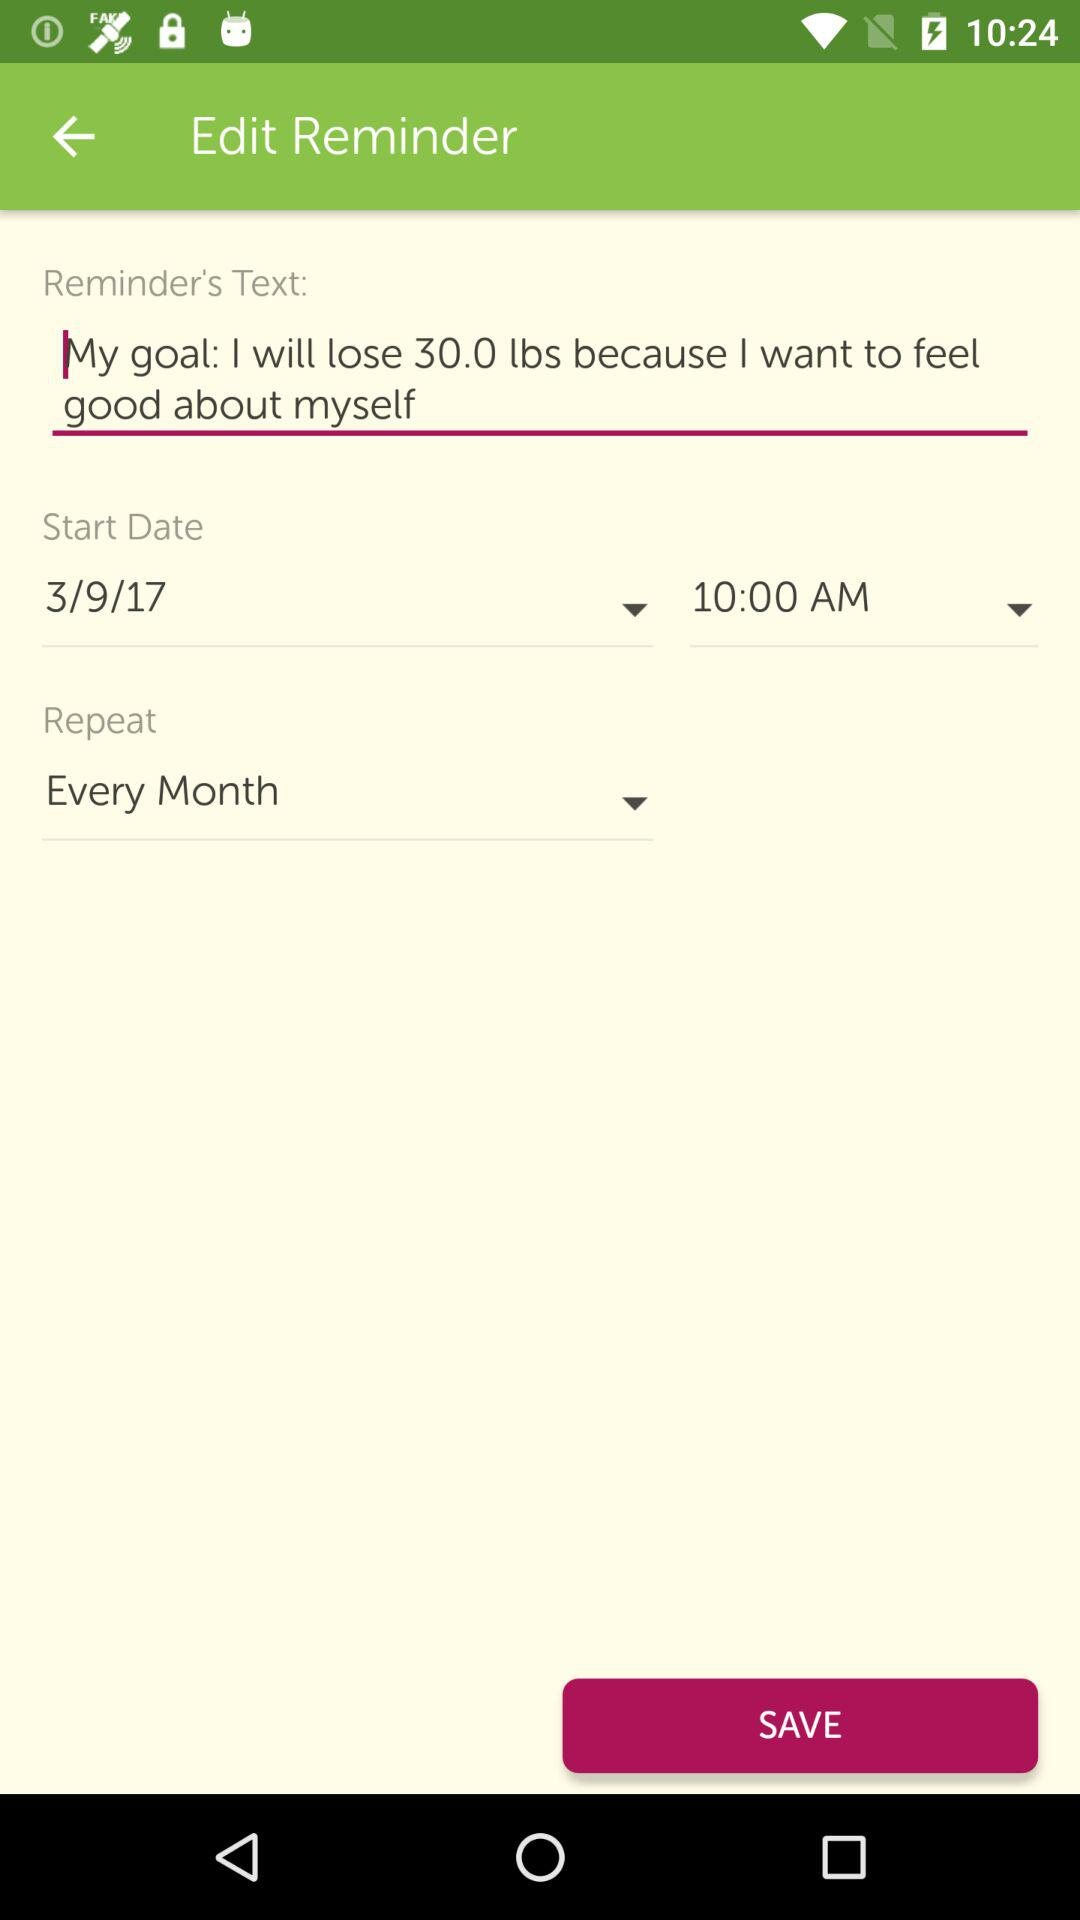What is the selected start date? The selected start date is March 9, 2017. 